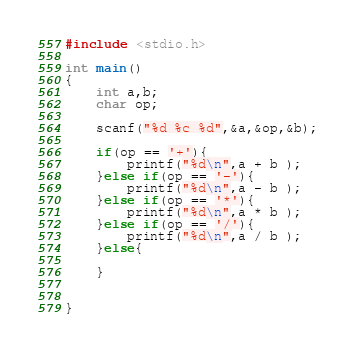Convert code to text. <code><loc_0><loc_0><loc_500><loc_500><_C_>#include <stdio.h>

int main()
{
	int a,b;
	char op;

	scanf("%d %c %d",&a,&op,&b);

	if(op == '+'){
		printf("%d\n",a + b );
	}else if(op == '-'){
		printf("%d\n",a - b );
	}else if(op == '*'){
		printf("%d\n",a * b );
	}else if(op == '/'){
		printf("%d\n",a / b );
	}else{
		
	}


}</code> 